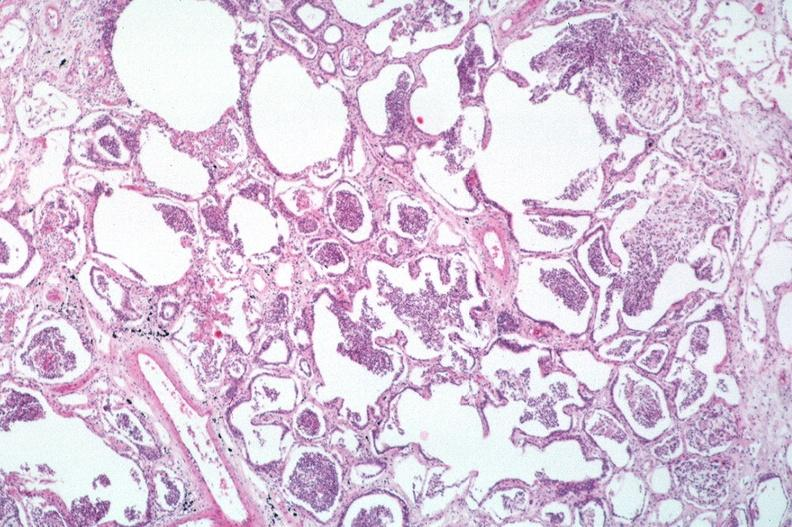s respiratory present?
Answer the question using a single word or phrase. Yes 